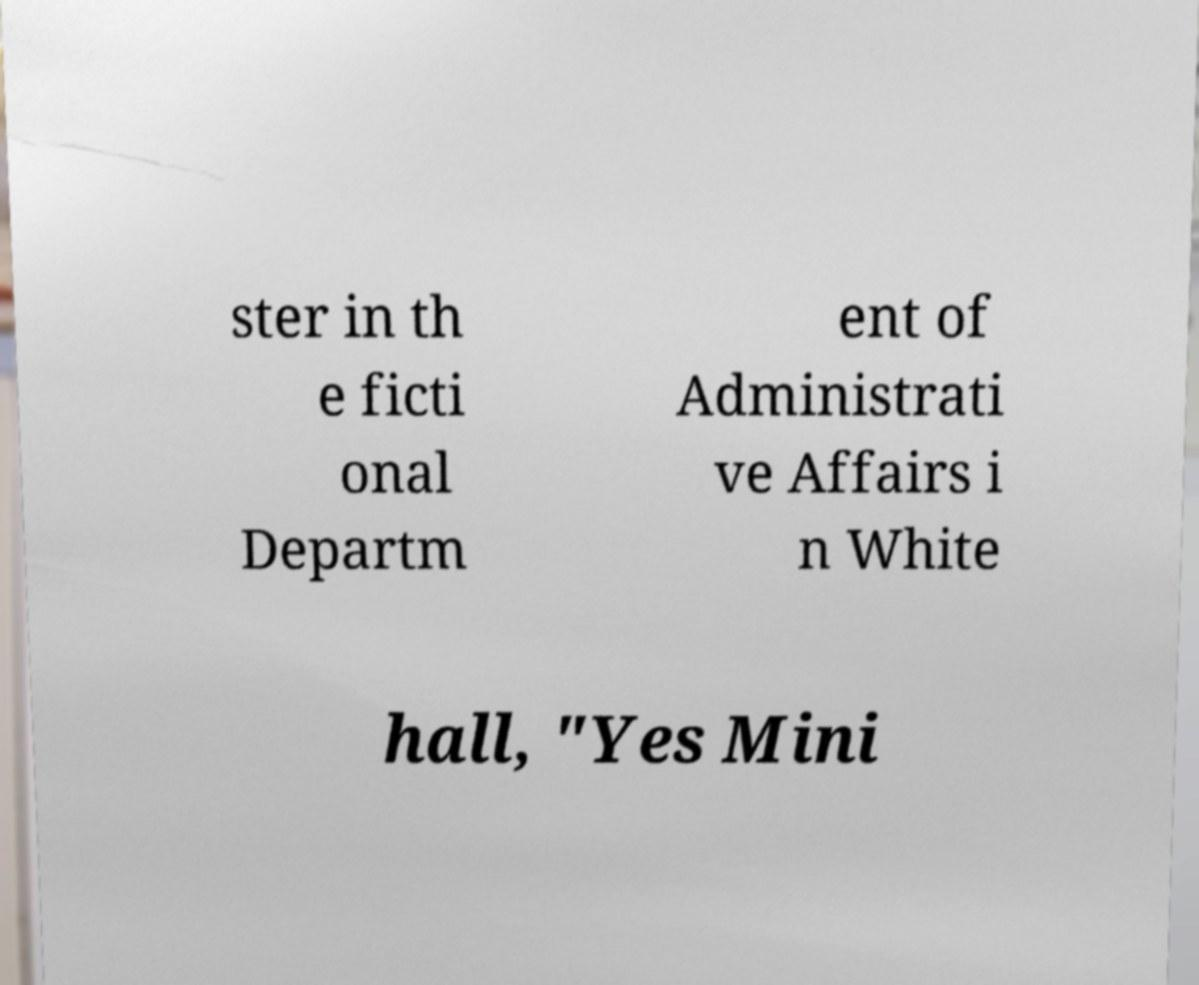Please identify and transcribe the text found in this image. ster in th e ficti onal Departm ent of Administrati ve Affairs i n White hall, "Yes Mini 